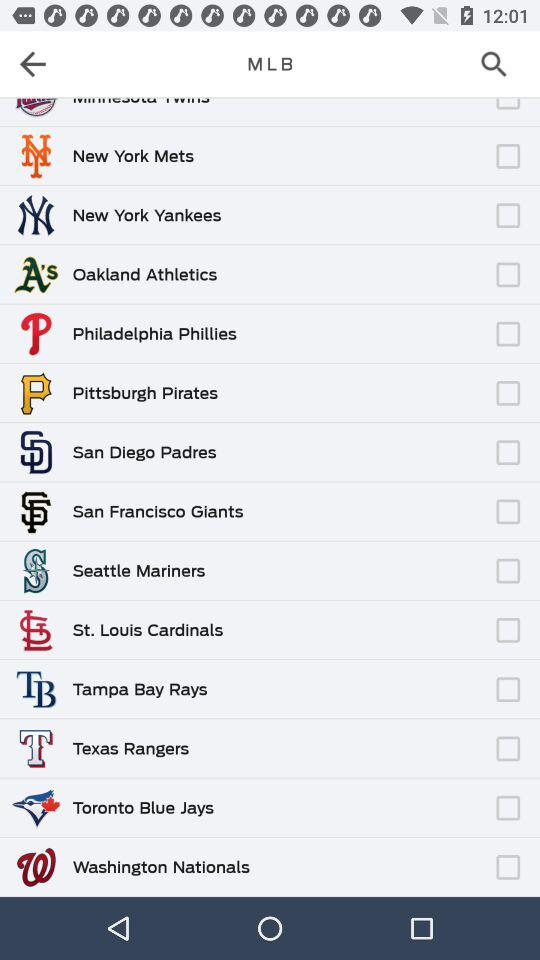What is the status of "Oakland Athletics"? The status is "off". 